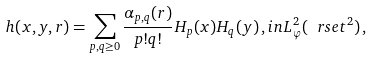<formula> <loc_0><loc_0><loc_500><loc_500>h ( x , y , r ) = \sum _ { p , q \geq 0 } \frac { \alpha _ { p , q } ( r ) } { p ! q ! } H _ { p } ( x ) H _ { q } ( y ) \, , i n L ^ { 2 } _ { \varphi } ( \ r s e t ^ { 2 } ) \, ,</formula> 